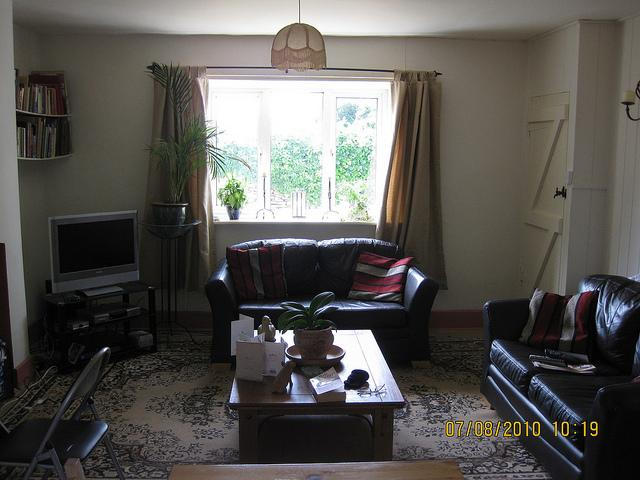What type of plant is on the coffee table? succulent 